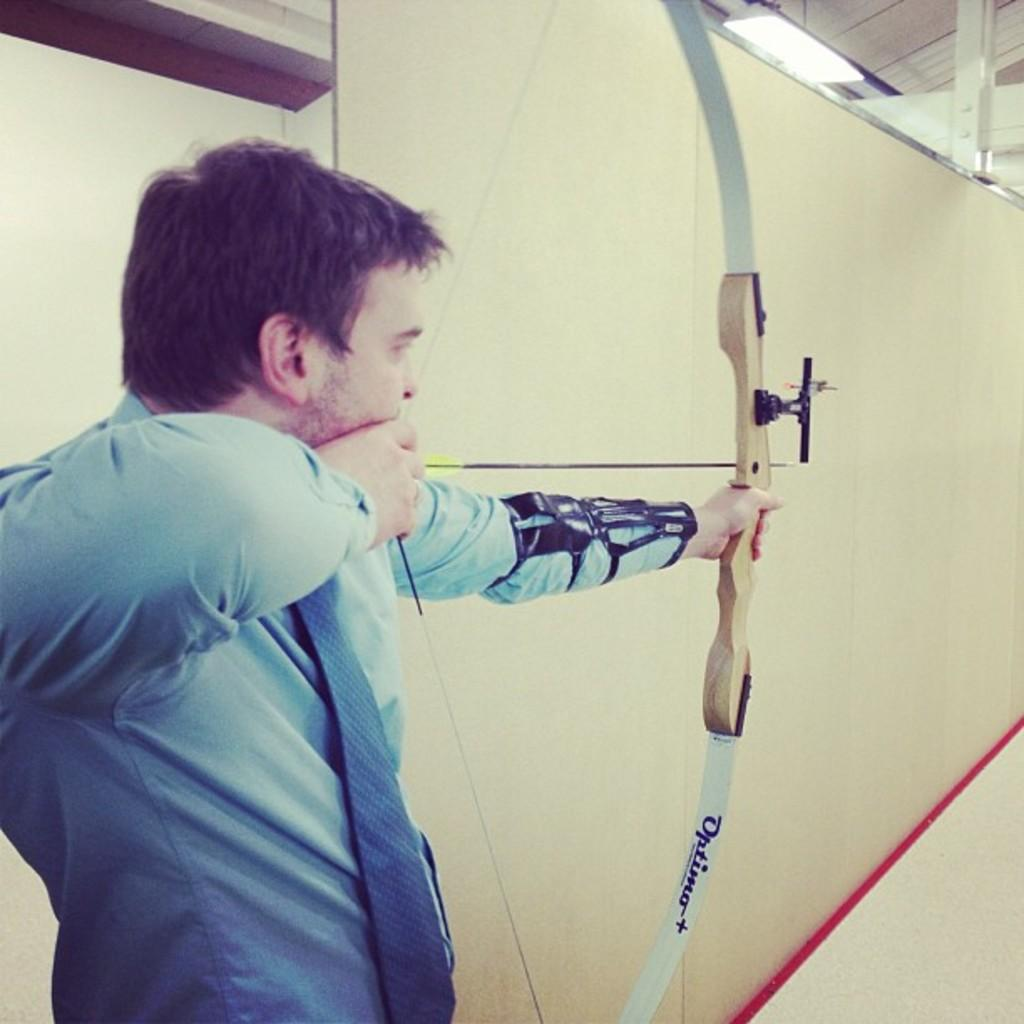What is the man in the image doing? The man is bowling an arrow. What can be inferred about the man's attire from the image? The man is wearing a blue dress. What type of glue is the man using to attach the basket to the wall in the image? There is no glue or basket present in the image; the man is bowling an arrow. 